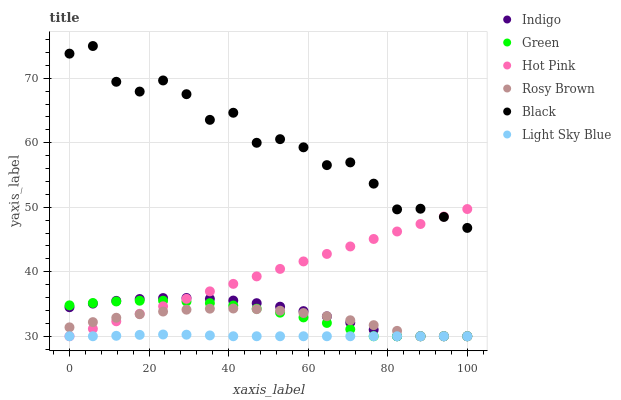Does Light Sky Blue have the minimum area under the curve?
Answer yes or no. Yes. Does Black have the maximum area under the curve?
Answer yes or no. Yes. Does Indigo have the minimum area under the curve?
Answer yes or no. No. Does Indigo have the maximum area under the curve?
Answer yes or no. No. Is Hot Pink the smoothest?
Answer yes or no. Yes. Is Black the roughest?
Answer yes or no. Yes. Is Indigo the smoothest?
Answer yes or no. No. Is Indigo the roughest?
Answer yes or no. No. Does Hot Pink have the lowest value?
Answer yes or no. Yes. Does Black have the lowest value?
Answer yes or no. No. Does Black have the highest value?
Answer yes or no. Yes. Does Indigo have the highest value?
Answer yes or no. No. Is Rosy Brown less than Black?
Answer yes or no. Yes. Is Black greater than Light Sky Blue?
Answer yes or no. Yes. Does Rosy Brown intersect Green?
Answer yes or no. Yes. Is Rosy Brown less than Green?
Answer yes or no. No. Is Rosy Brown greater than Green?
Answer yes or no. No. Does Rosy Brown intersect Black?
Answer yes or no. No. 